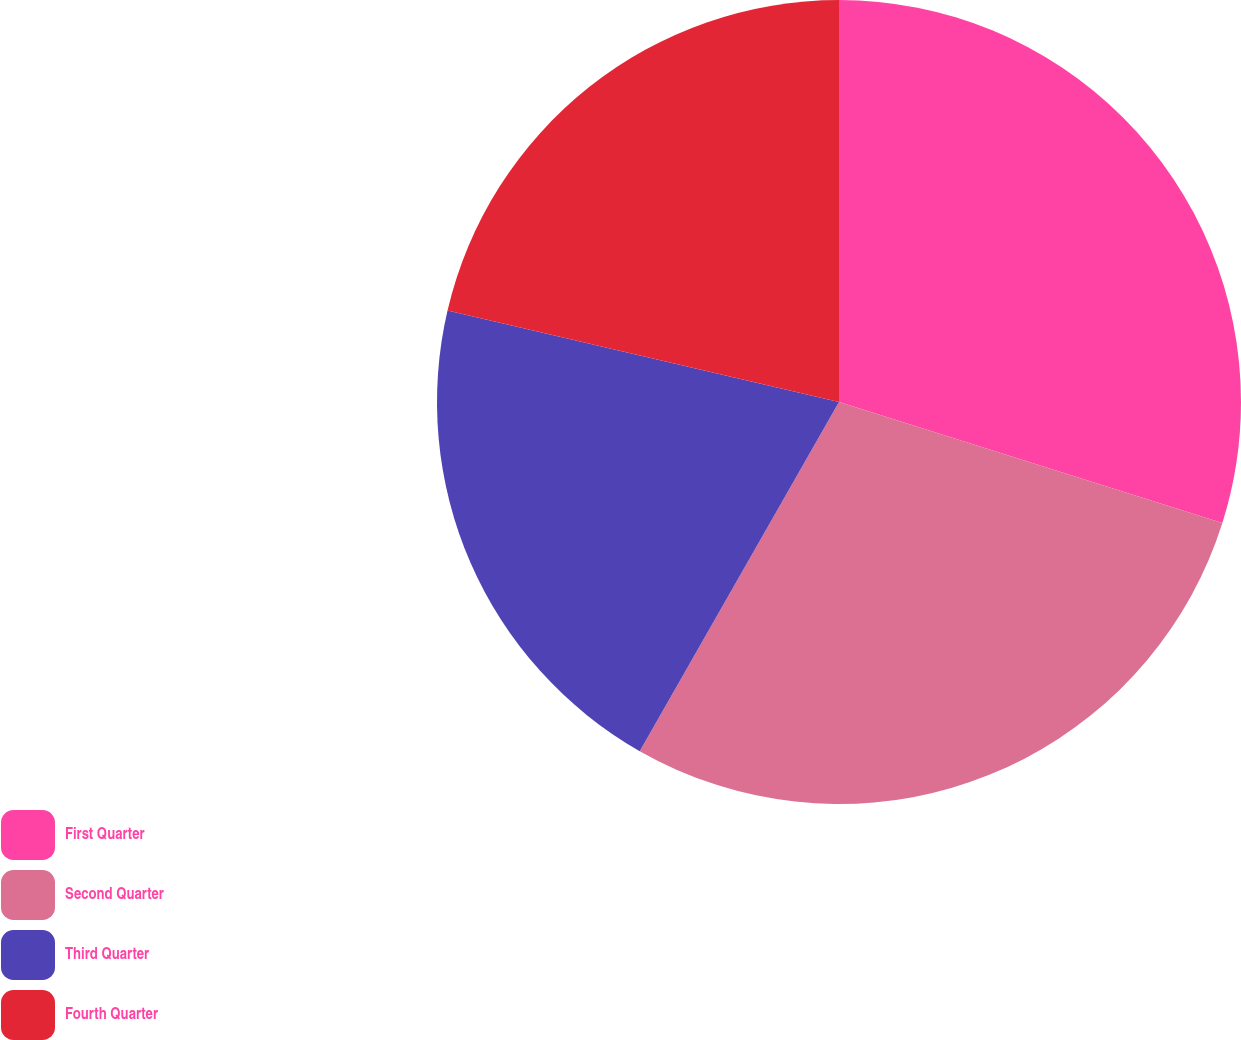<chart> <loc_0><loc_0><loc_500><loc_500><pie_chart><fcel>First Quarter<fcel>Second Quarter<fcel>Third Quarter<fcel>Fourth Quarter<nl><fcel>29.87%<fcel>28.39%<fcel>20.4%<fcel>21.35%<nl></chart> 